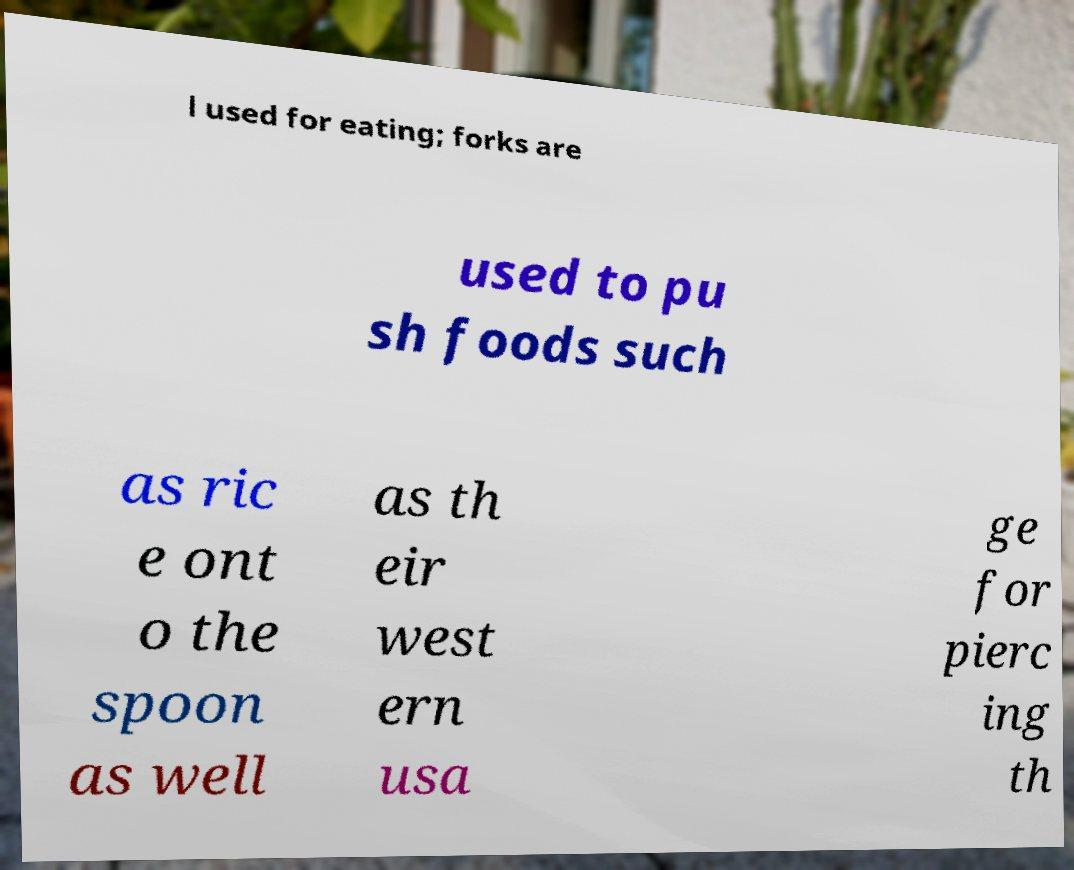What messages or text are displayed in this image? I need them in a readable, typed format. l used for eating; forks are used to pu sh foods such as ric e ont o the spoon as well as th eir west ern usa ge for pierc ing th 